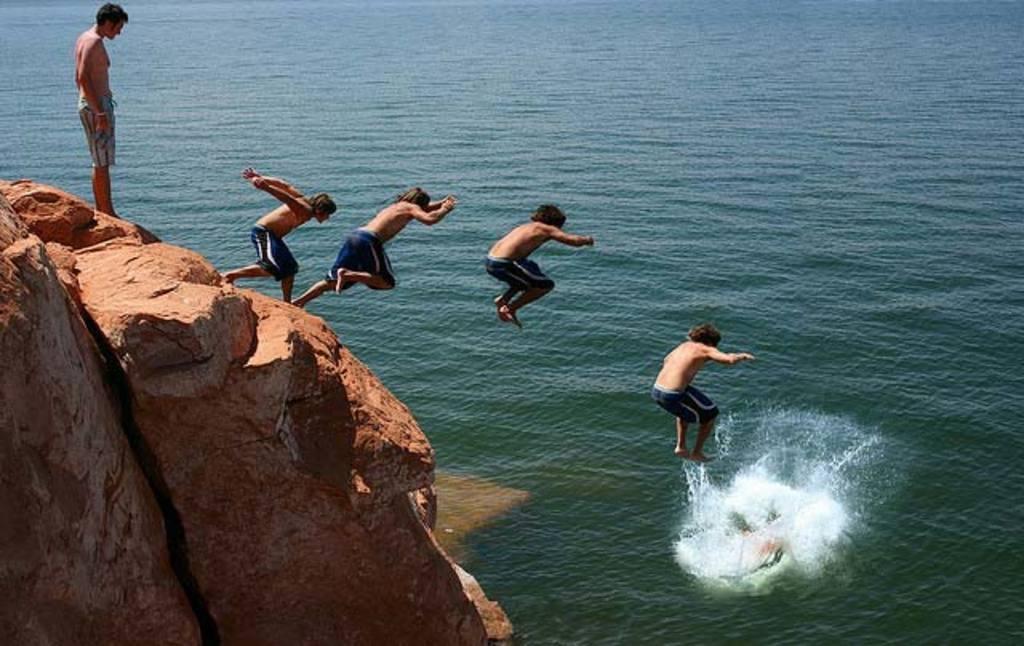How would you summarize this image in a sentence or two? In the picture I can see a person in the water and there are three persons in the air above him and there are two persons standing on the rock in the left corner and there is water in the background. 